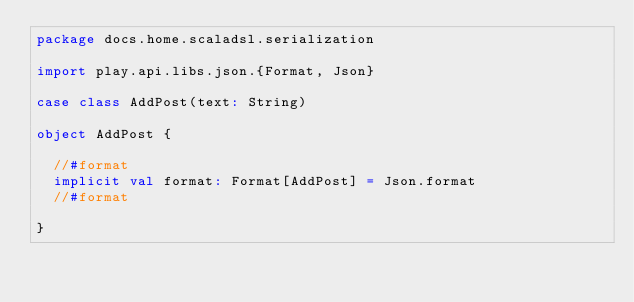Convert code to text. <code><loc_0><loc_0><loc_500><loc_500><_Scala_>package docs.home.scaladsl.serialization

import play.api.libs.json.{Format, Json}

case class AddPost(text: String)

object AddPost {

  //#format
  implicit val format: Format[AddPost] = Json.format
  //#format

}</code> 